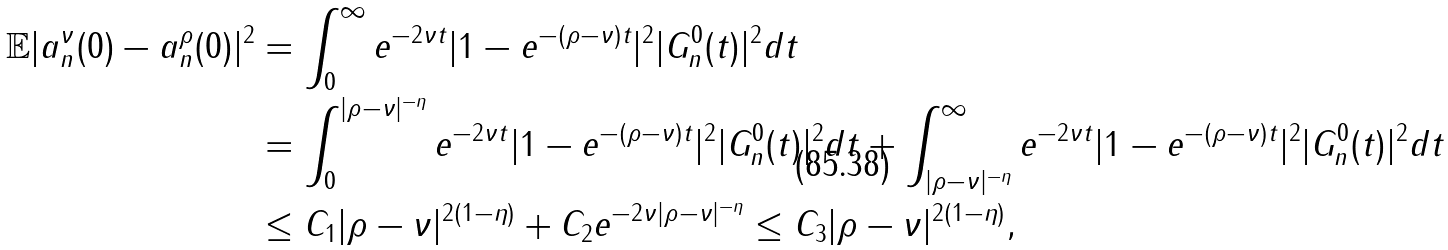Convert formula to latex. <formula><loc_0><loc_0><loc_500><loc_500>\mathbb { E } | a _ { n } ^ { \nu } ( 0 ) - a _ { n } ^ { \rho } ( 0 ) | ^ { 2 } & = \int _ { 0 } ^ { \infty } e ^ { - 2 \nu t } | 1 - e ^ { - ( \rho - \nu ) t } | ^ { 2 } | G _ { n } ^ { 0 } ( t ) | ^ { 2 } d t \\ & = \int _ { 0 } ^ { | \rho - \nu | ^ { - \eta } } e ^ { - 2 \nu t } | 1 - e ^ { - ( \rho - \nu ) t } | ^ { 2 } | G _ { n } ^ { 0 } ( t ) | ^ { 2 } d t + \int _ { | \rho - \nu | ^ { - \eta } } ^ { \infty } e ^ { - 2 \nu t } | 1 - e ^ { - ( \rho - \nu ) t } | ^ { 2 } | G _ { n } ^ { 0 } ( t ) | ^ { 2 } d t \\ & \leq C _ { 1 } | \rho - \nu | ^ { 2 ( 1 - \eta ) } + C _ { 2 } e ^ { - 2 \nu | \rho - \nu | ^ { - \eta } } \leq C _ { 3 } | \rho - \nu | ^ { 2 ( 1 - \eta ) } ,</formula> 